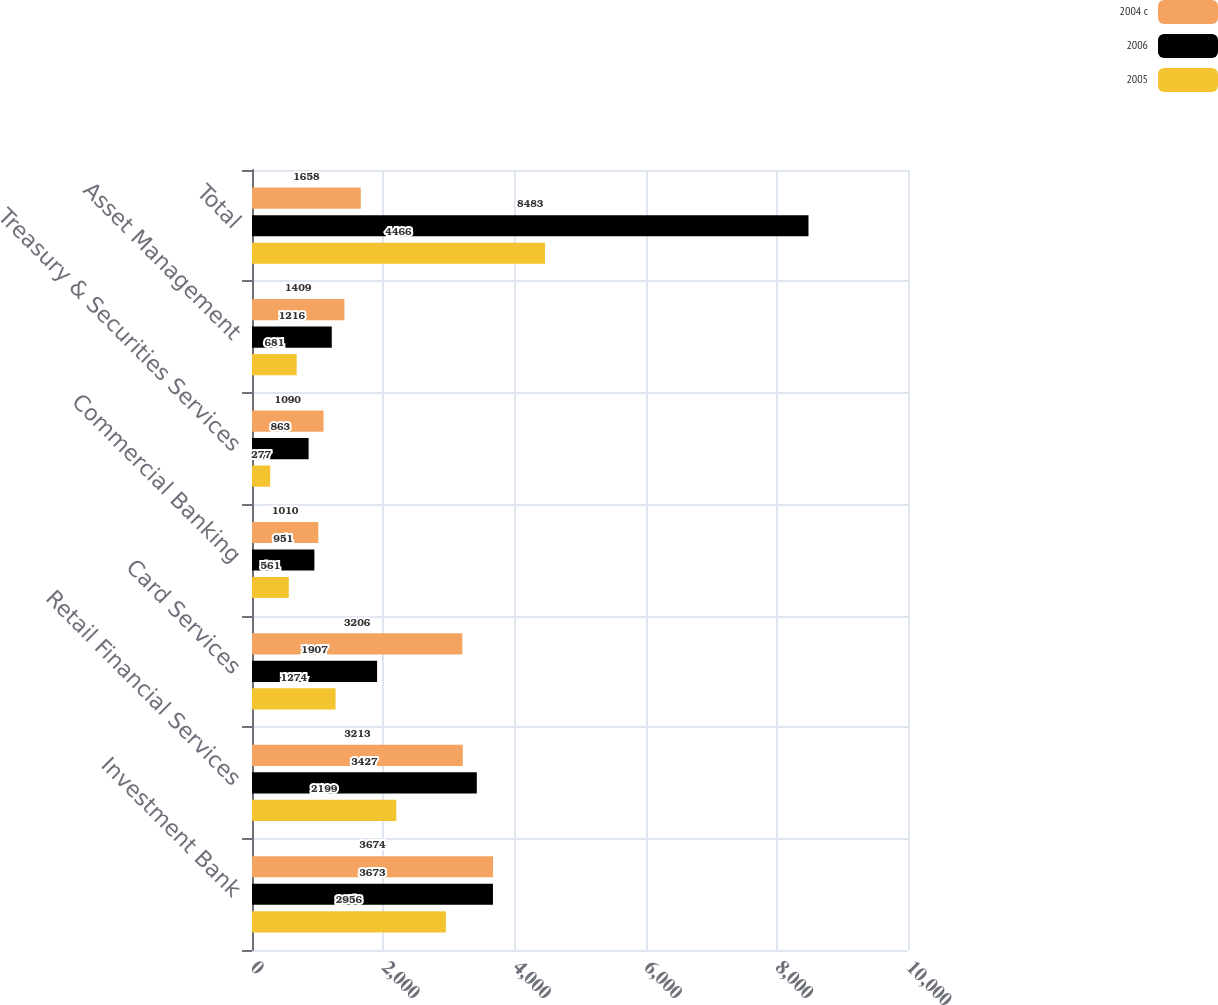Convert chart to OTSL. <chart><loc_0><loc_0><loc_500><loc_500><stacked_bar_chart><ecel><fcel>Investment Bank<fcel>Retail Financial Services<fcel>Card Services<fcel>Commercial Banking<fcel>Treasury & Securities Services<fcel>Asset Management<fcel>Total<nl><fcel>2004 c<fcel>3674<fcel>3213<fcel>3206<fcel>1010<fcel>1090<fcel>1409<fcel>1658<nl><fcel>2006<fcel>3673<fcel>3427<fcel>1907<fcel>951<fcel>863<fcel>1216<fcel>8483<nl><fcel>2005<fcel>2956<fcel>2199<fcel>1274<fcel>561<fcel>277<fcel>681<fcel>4466<nl></chart> 